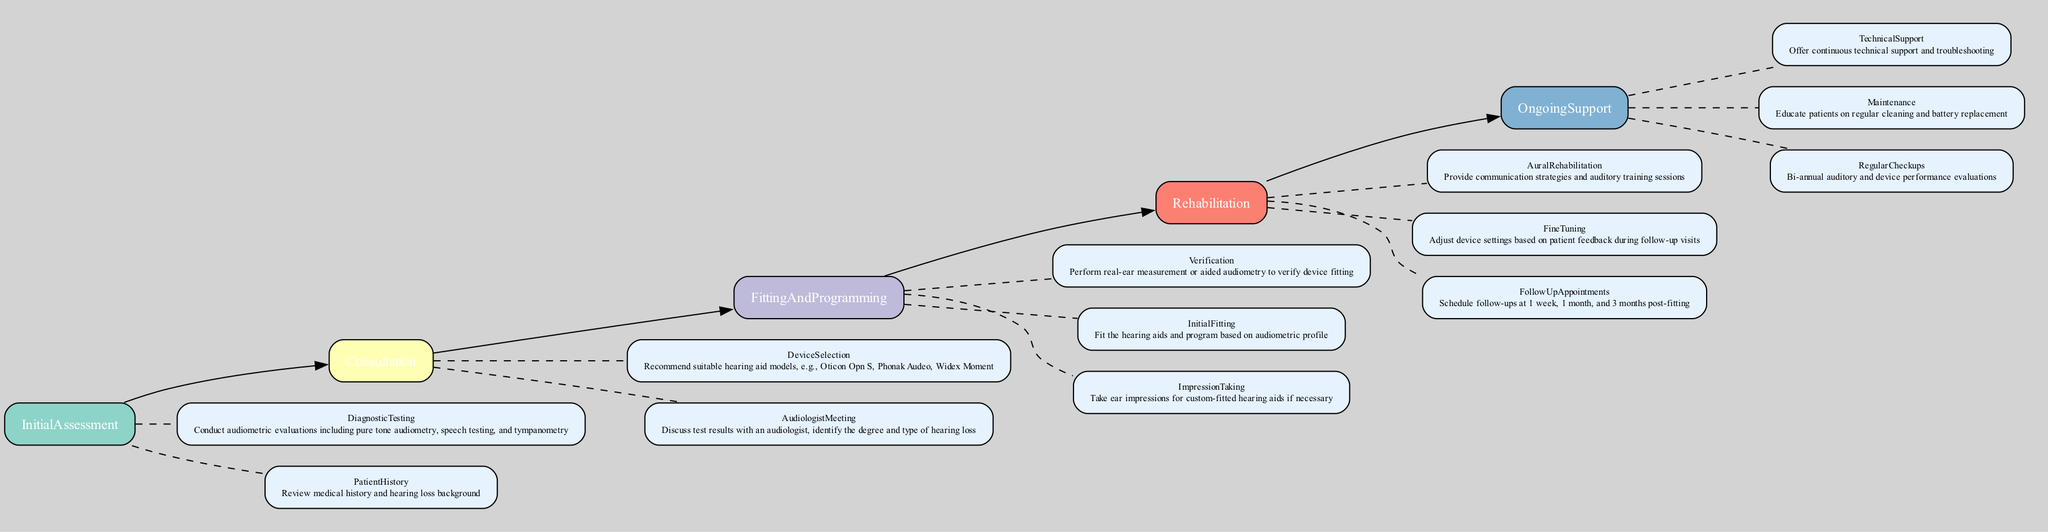What is the first stage in the rehabilitation pathway? The diagram outlines the first stage as "InitialAssessment". This can be found at the beginning of the pathway sequence.
Answer: Initial Assessment How many main stages are there in the pathway? By counting the distinct main stages listed in the diagram, there are five stages: Initial Assessment, Consultation, Fitting and Programming, Rehabilitation, and Ongoing Support.
Answer: 5 What occurs after the "Device Selection" step? The flow of the diagram indicates that after "DeviceSelection", the next step is "FittingAndProgramming". This is derived from the connection between these two stages.
Answer: Fitting and Programming Which step involves adjustments based on patient feedback? The diagram specifies that "FineTuning" is the step where adjustments are made according to the feedback provided by patients during follow-up visits.
Answer: Fine Tuning What type of evaluations are conducted in the "Initial Assessment"? The "InitialAssessment" stage includes "DiagnosticTesting", which consists of audiometric evaluations such as pure tone audiometry and speech testing, as indicated in this stage's subprocesses.
Answer: Audiometric evaluations Which stage includes providing communication strategies? The "Rehabilitation" stage includes providing "AuralRehabilitation", which focuses specifically on communication strategies and auditory training sessions for the patient, as shown in the subprocesses of this stage.
Answer: Aural Rehabilitation What is the purpose of "Regular Checkups"? The "RegularCheckups" step in the "OngoingSupport" stage serves the purpose of bi-annual auditory and device performance evaluations, as outlined in its description.
Answer: Bi-annual evaluations What does the "Impression Taking" step refer to? In the "FittingAndProgramming" stage, "ImpressionTaking" refers to taking ear impressions for custom-fitted hearing aids, which is explicitly stated in the subprocesses of that stage.
Answer: Ear impressions for custom-fitted hearing aids 